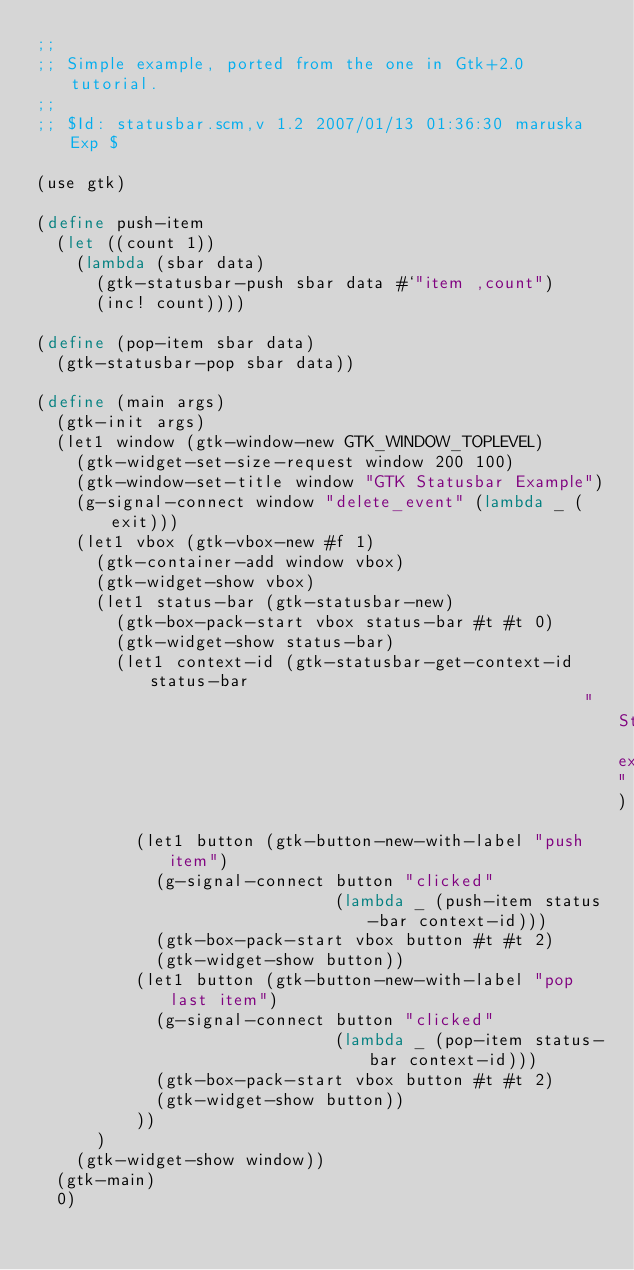<code> <loc_0><loc_0><loc_500><loc_500><_Scheme_>;;
;; Simple example, ported from the one in Gtk+2.0 tutorial.
;;
;; $Id: statusbar.scm,v 1.2 2007/01/13 01:36:30 maruska Exp $

(use gtk)

(define push-item
  (let ((count 1))
    (lambda (sbar data)
      (gtk-statusbar-push sbar data #`"item ,count")
      (inc! count))))

(define (pop-item sbar data)
  (gtk-statusbar-pop sbar data))

(define (main args)
  (gtk-init args)
  (let1 window (gtk-window-new GTK_WINDOW_TOPLEVEL)
    (gtk-widget-set-size-request window 200 100)
    (gtk-window-set-title window "GTK Statusbar Example")
    (g-signal-connect window "delete_event" (lambda _ (exit)))
    (let1 vbox (gtk-vbox-new #f 1)
      (gtk-container-add window vbox)
      (gtk-widget-show vbox)
      (let1 status-bar (gtk-statusbar-new)
        (gtk-box-pack-start vbox status-bar #t #t 0)
        (gtk-widget-show status-bar)
        (let1 context-id (gtk-statusbar-get-context-id status-bar
                                                       "Statusbar example")
          (let1 button (gtk-button-new-with-label "push item")
            (g-signal-connect button "clicked"
                              (lambda _ (push-item status-bar context-id)))
            (gtk-box-pack-start vbox button #t #t 2)
            (gtk-widget-show button))
          (let1 button (gtk-button-new-with-label "pop last item")
            (g-signal-connect button "clicked"
                              (lambda _ (pop-item status-bar context-id)))
            (gtk-box-pack-start vbox button #t #t 2)
            (gtk-widget-show button))
          ))
      )
    (gtk-widget-show window))
  (gtk-main)
  0)
</code> 